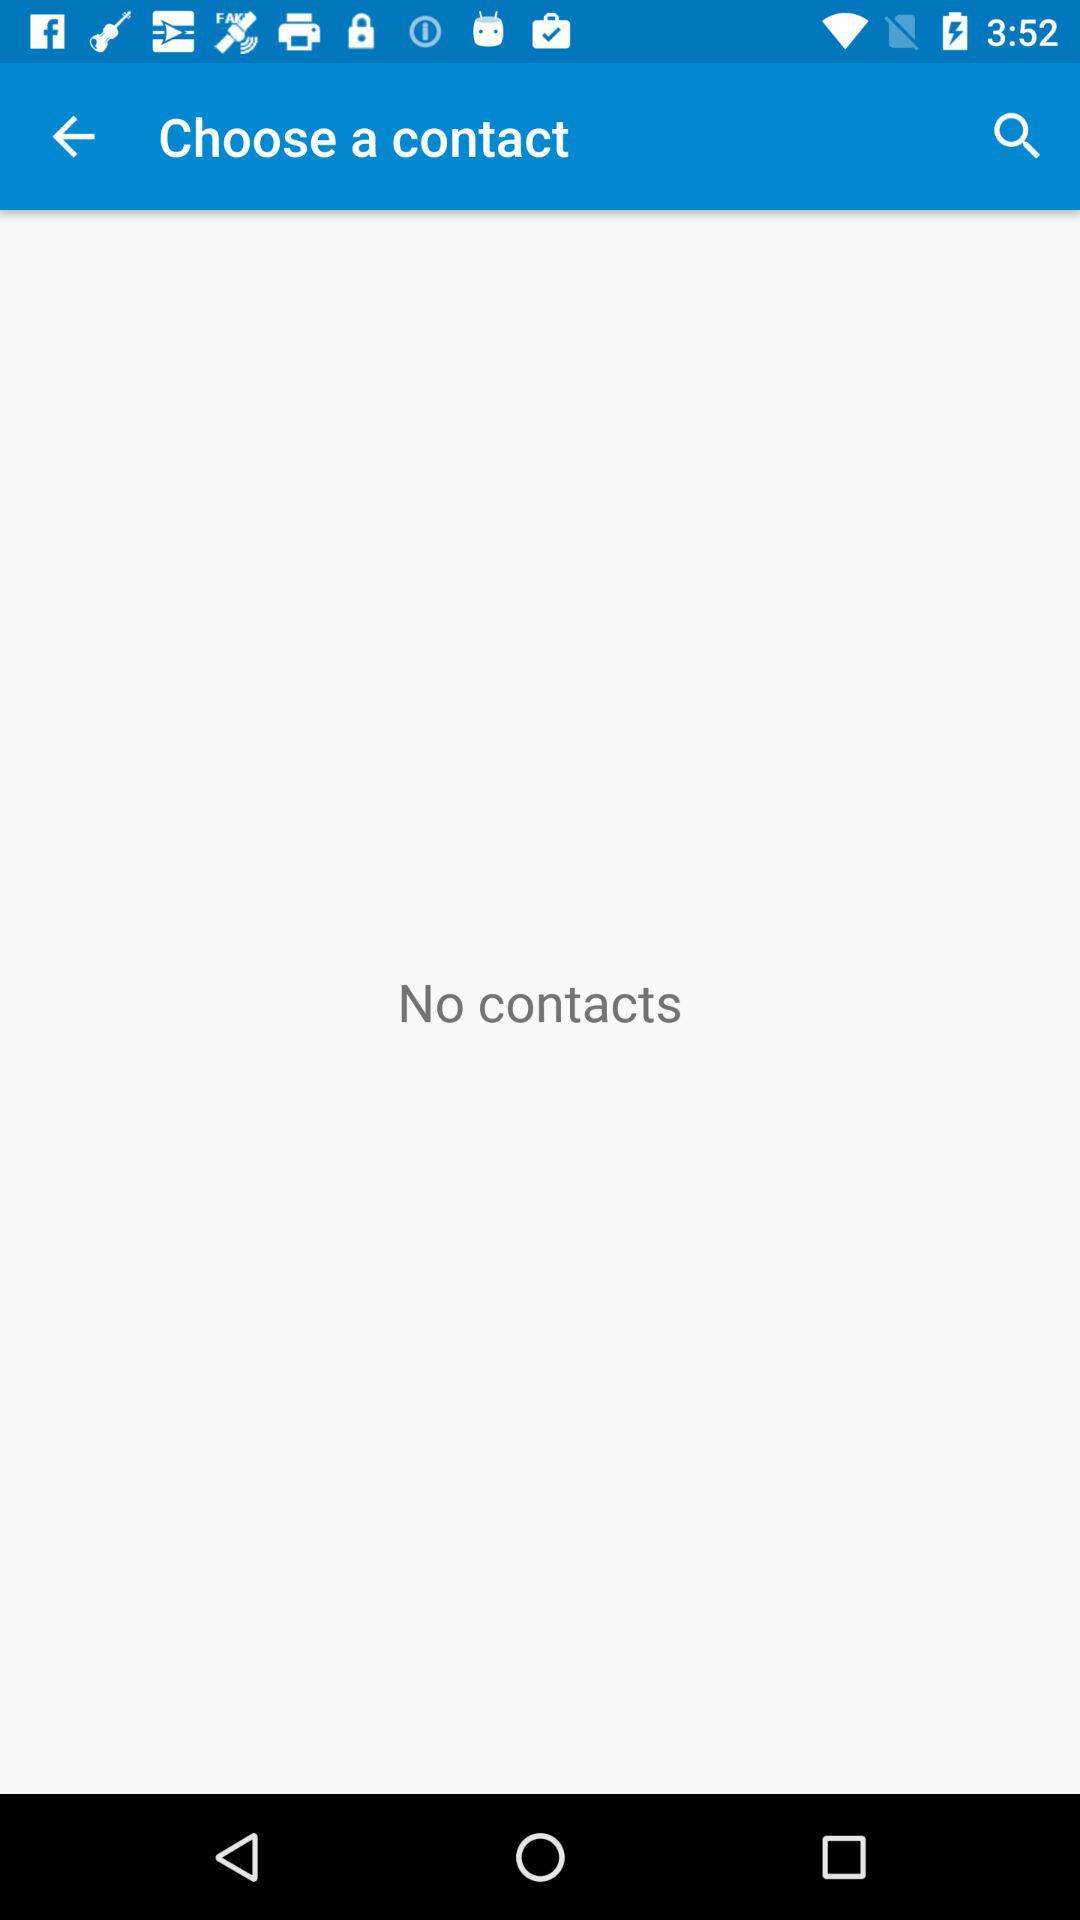Are there any contacts? There are no contacts. 